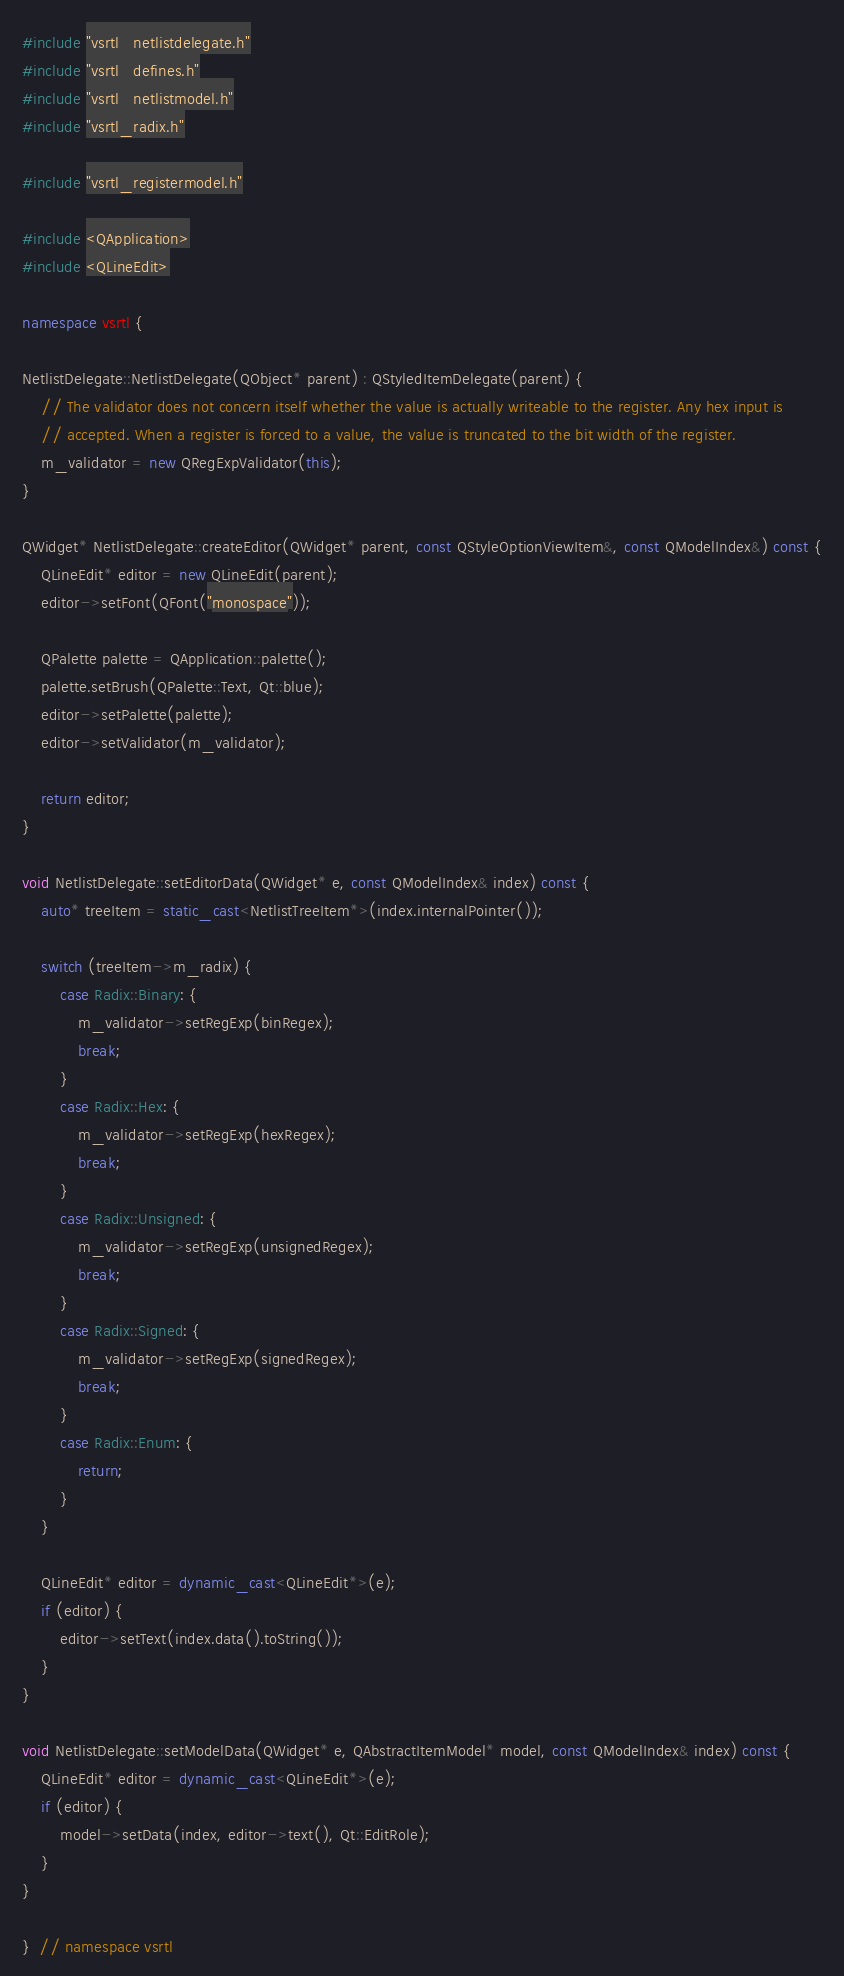Convert code to text. <code><loc_0><loc_0><loc_500><loc_500><_C++_>#include "vsrtl_netlistdelegate.h"
#include "vsrtl_defines.h"
#include "vsrtl_netlistmodel.h"
#include "vsrtl_radix.h"

#include "vsrtl_registermodel.h"

#include <QApplication>
#include <QLineEdit>

namespace vsrtl {

NetlistDelegate::NetlistDelegate(QObject* parent) : QStyledItemDelegate(parent) {
    // The validator does not concern itself whether the value is actually writeable to the register. Any hex input is
    // accepted. When a register is forced to a value, the value is truncated to the bit width of the register.
    m_validator = new QRegExpValidator(this);
}

QWidget* NetlistDelegate::createEditor(QWidget* parent, const QStyleOptionViewItem&, const QModelIndex&) const {
    QLineEdit* editor = new QLineEdit(parent);
    editor->setFont(QFont("monospace"));

    QPalette palette = QApplication::palette();
    palette.setBrush(QPalette::Text, Qt::blue);
    editor->setPalette(palette);
    editor->setValidator(m_validator);

    return editor;
}

void NetlistDelegate::setEditorData(QWidget* e, const QModelIndex& index) const {
    auto* treeItem = static_cast<NetlistTreeItem*>(index.internalPointer());

    switch (treeItem->m_radix) {
        case Radix::Binary: {
            m_validator->setRegExp(binRegex);
            break;
        }
        case Radix::Hex: {
            m_validator->setRegExp(hexRegex);
            break;
        }
        case Radix::Unsigned: {
            m_validator->setRegExp(unsignedRegex);
            break;
        }
        case Radix::Signed: {
            m_validator->setRegExp(signedRegex);
            break;
        }
        case Radix::Enum: {
            return;
        }
    }

    QLineEdit* editor = dynamic_cast<QLineEdit*>(e);
    if (editor) {
        editor->setText(index.data().toString());
    }
}

void NetlistDelegate::setModelData(QWidget* e, QAbstractItemModel* model, const QModelIndex& index) const {
    QLineEdit* editor = dynamic_cast<QLineEdit*>(e);
    if (editor) {
        model->setData(index, editor->text(), Qt::EditRole);
    }
}

}  // namespace vsrtl
</code> 